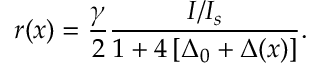Convert formula to latex. <formula><loc_0><loc_0><loc_500><loc_500>r ( x ) = \frac { \gamma } { 2 } \frac { I / I _ { s } } { 1 + 4 \left [ \Delta _ { 0 } + \Delta ( x ) \right ] } .</formula> 